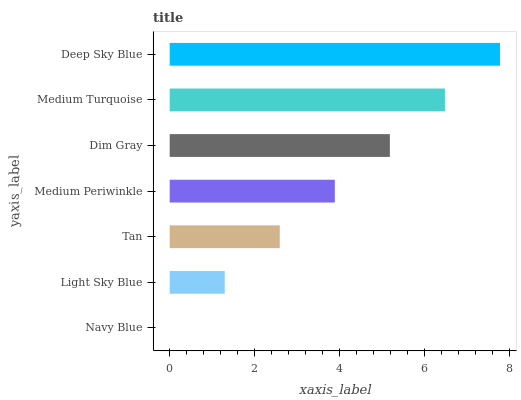Is Navy Blue the minimum?
Answer yes or no. Yes. Is Deep Sky Blue the maximum?
Answer yes or no. Yes. Is Light Sky Blue the minimum?
Answer yes or no. No. Is Light Sky Blue the maximum?
Answer yes or no. No. Is Light Sky Blue greater than Navy Blue?
Answer yes or no. Yes. Is Navy Blue less than Light Sky Blue?
Answer yes or no. Yes. Is Navy Blue greater than Light Sky Blue?
Answer yes or no. No. Is Light Sky Blue less than Navy Blue?
Answer yes or no. No. Is Medium Periwinkle the high median?
Answer yes or no. Yes. Is Medium Periwinkle the low median?
Answer yes or no. Yes. Is Light Sky Blue the high median?
Answer yes or no. No. Is Deep Sky Blue the low median?
Answer yes or no. No. 